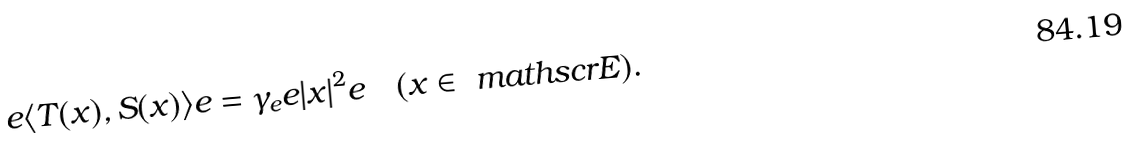<formula> <loc_0><loc_0><loc_500><loc_500>e \langle T ( x ) , S ( x ) \rangle e = \gamma _ { e } e | x | ^ { 2 } e \quad ( x \in \ m a t h s c r { E } ) .</formula> 